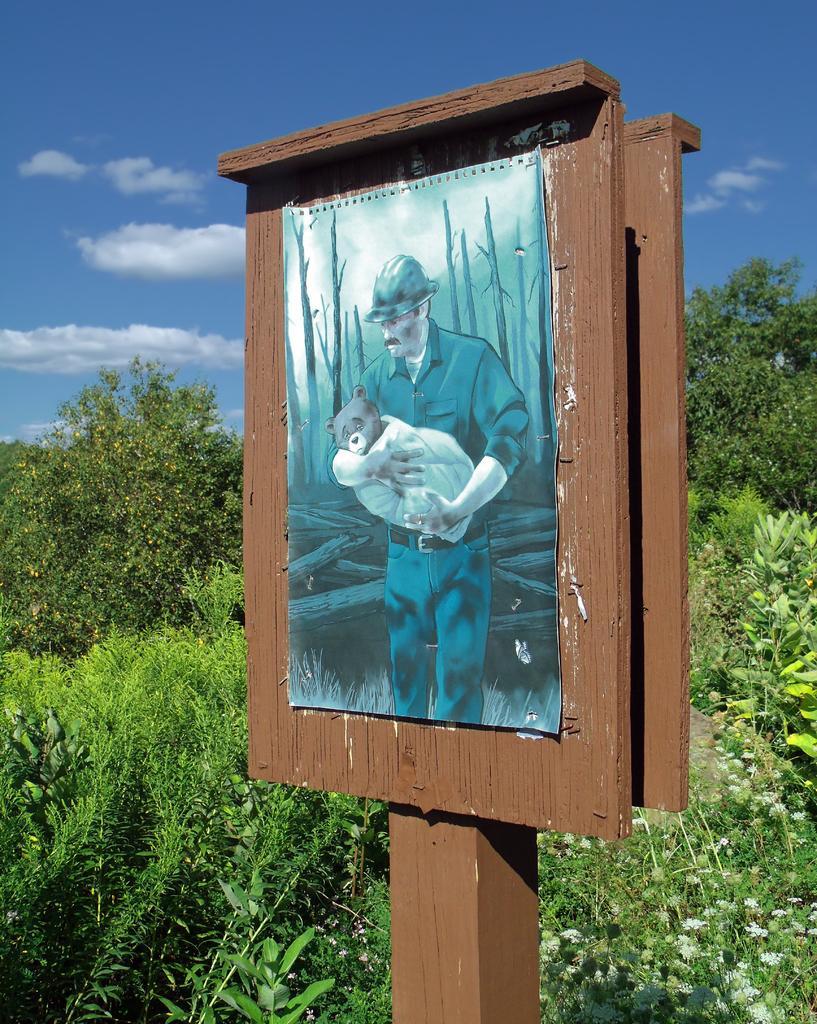Describe this image in one or two sentences. In this picture we can see a photo of a man wore a helmet and holding an animal with his hands on a board. In the background we can see trees and the sky with clouds. 